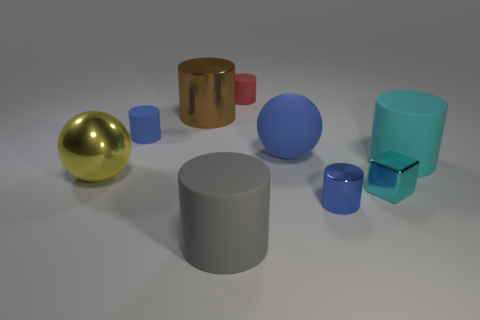Subtract 4 cylinders. How many cylinders are left? 2 Subtract all cyan cylinders. How many cylinders are left? 5 Subtract all blue cylinders. How many cylinders are left? 4 Subtract all purple cylinders. Subtract all yellow blocks. How many cylinders are left? 6 Subtract all spheres. How many objects are left? 7 Subtract all big blue things. Subtract all large blue rubber things. How many objects are left? 7 Add 8 big yellow balls. How many big yellow balls are left? 9 Add 5 big gray matte cylinders. How many big gray matte cylinders exist? 6 Subtract 1 cyan cylinders. How many objects are left? 8 